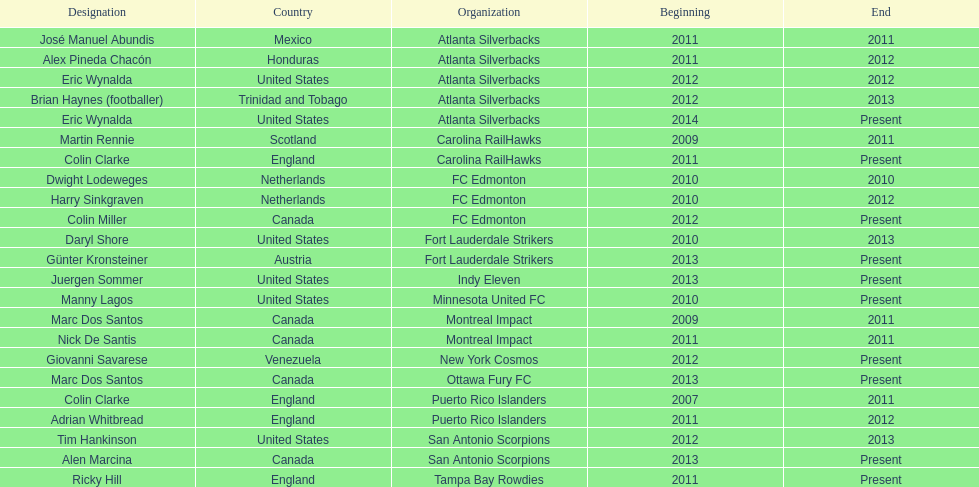How many total coaches on the list are from canada? 5. 